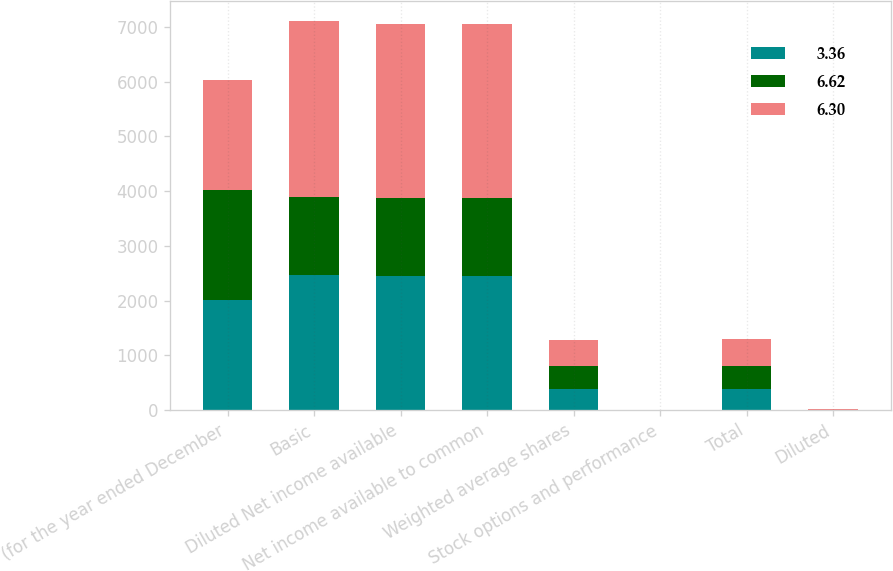Convert chart to OTSL. <chart><loc_0><loc_0><loc_500><loc_500><stacked_bar_chart><ecel><fcel>(for the year ended December<fcel>Basic<fcel>Diluted Net income available<fcel>Net income available to common<fcel>Weighted average shares<fcel>Stock options and performance<fcel>Total<fcel>Diluted<nl><fcel>3.36<fcel>2012<fcel>2473<fcel>2454<fcel>2454<fcel>386.2<fcel>3.6<fcel>389.8<fcel>6.3<nl><fcel>6.62<fcel>2011<fcel>1426<fcel>1414<fcel>1415<fcel>415.8<fcel>4<fcel>420.5<fcel>3.36<nl><fcel>6.3<fcel>2010<fcel>3216<fcel>3188<fcel>3193<fcel>476.5<fcel>4.2<fcel>482.5<fcel>6.62<nl></chart> 